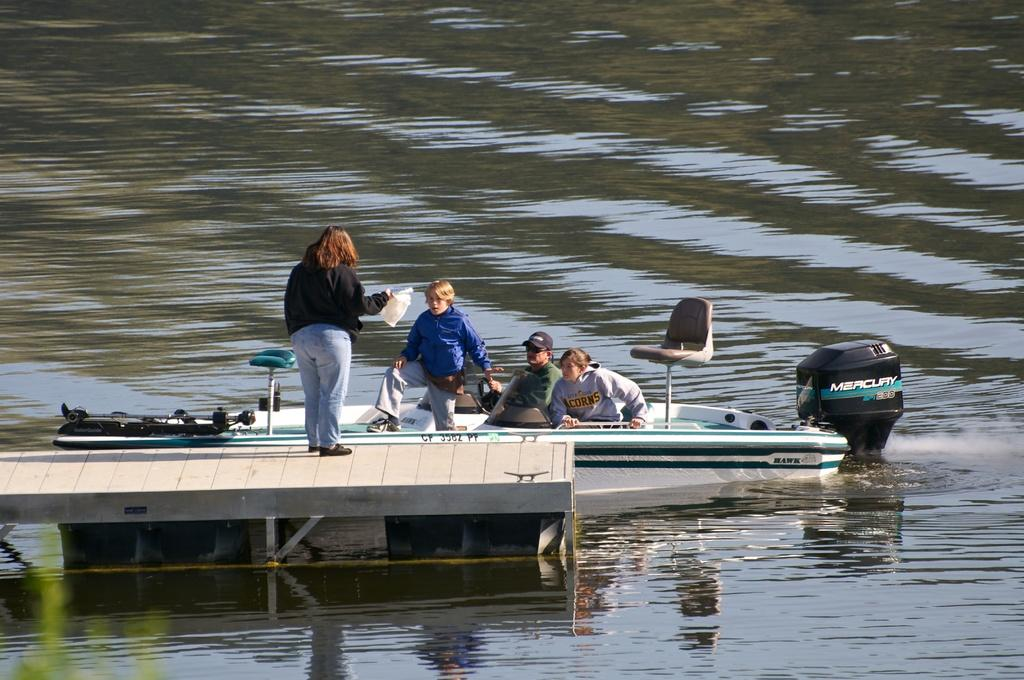What is the main subject in the center of the image? There is a boat in the center of the image. Are there any people in the boat? Yes, there are people in the boat. What can be seen at the bottom of the image? There is water visible at the bottom of the image. What type of yarn is being used by the people in the boat? There is no yarn present in the image; it features a boat with people on water. 